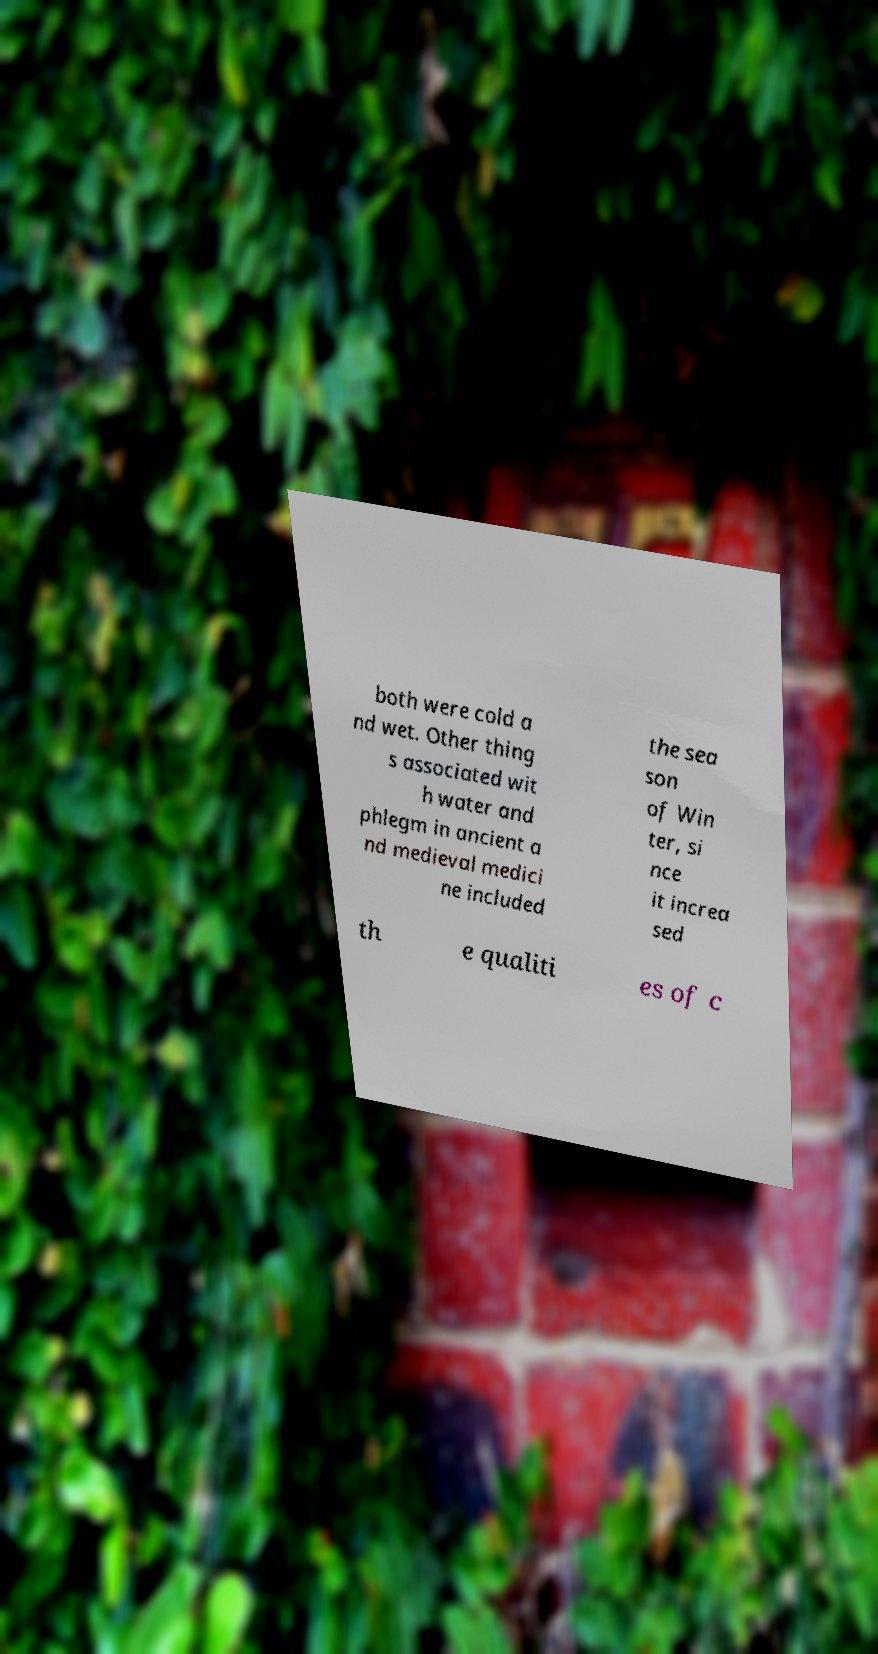I need the written content from this picture converted into text. Can you do that? both were cold a nd wet. Other thing s associated wit h water and phlegm in ancient a nd medieval medici ne included the sea son of Win ter, si nce it increa sed th e qualiti es of c 